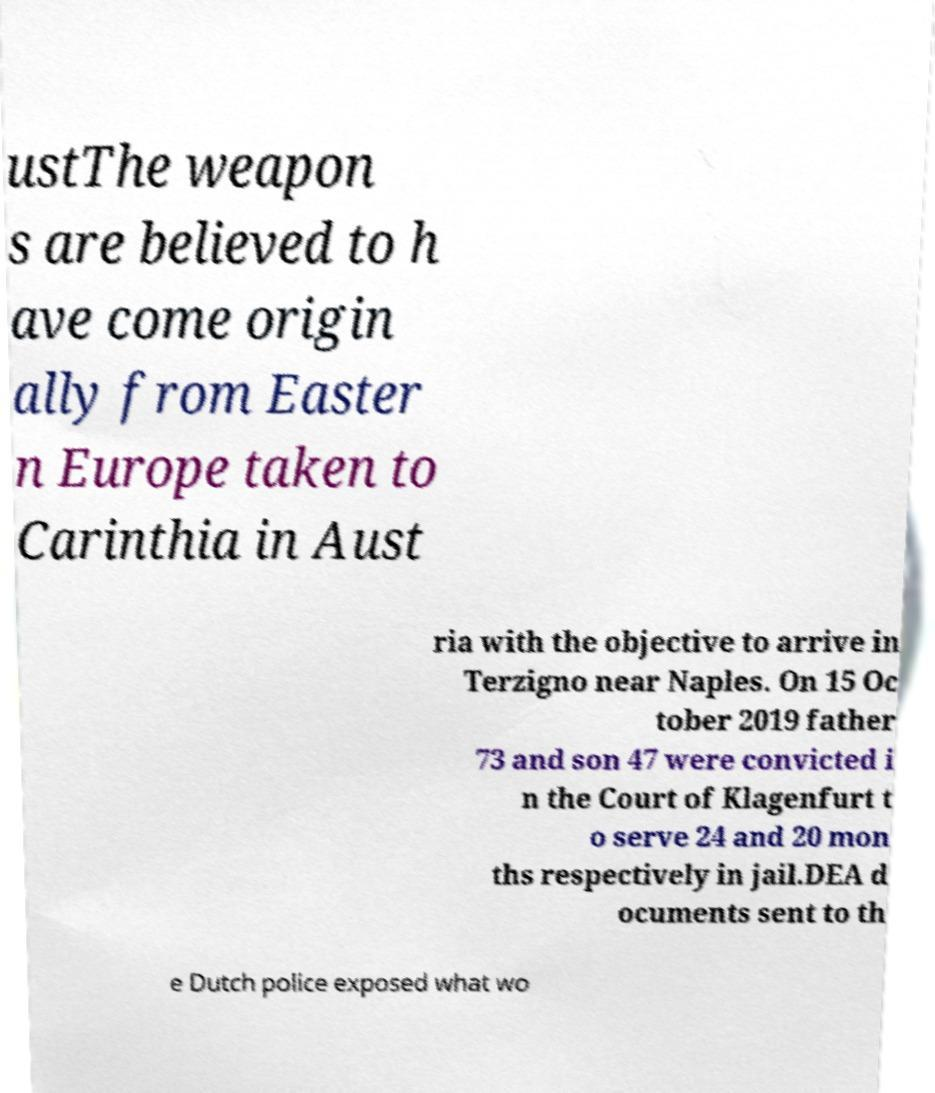Please identify and transcribe the text found in this image. ustThe weapon s are believed to h ave come origin ally from Easter n Europe taken to Carinthia in Aust ria with the objective to arrive in Terzigno near Naples. On 15 Oc tober 2019 father 73 and son 47 were convicted i n the Court of Klagenfurt t o serve 24 and 20 mon ths respectively in jail.DEA d ocuments sent to th e Dutch police exposed what wo 